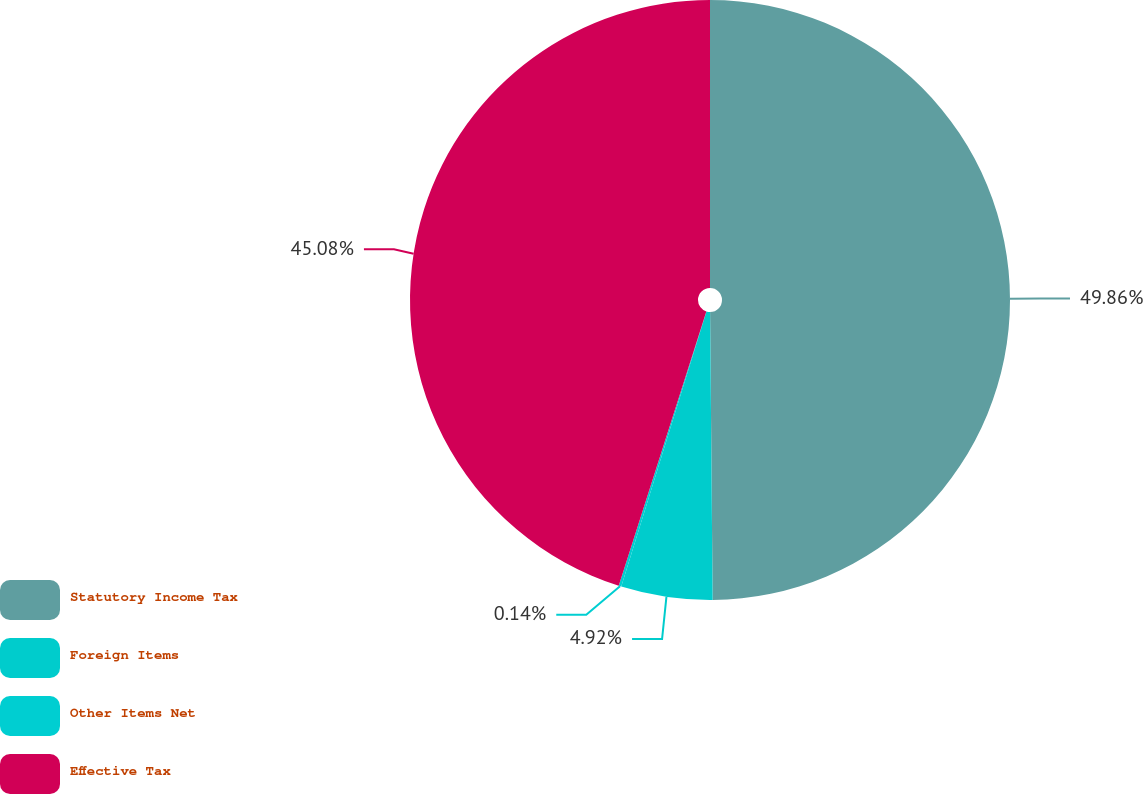Convert chart to OTSL. <chart><loc_0><loc_0><loc_500><loc_500><pie_chart><fcel>Statutory Income Tax<fcel>Foreign Items<fcel>Other Items Net<fcel>Effective Tax<nl><fcel>49.86%<fcel>4.92%<fcel>0.14%<fcel>45.08%<nl></chart> 